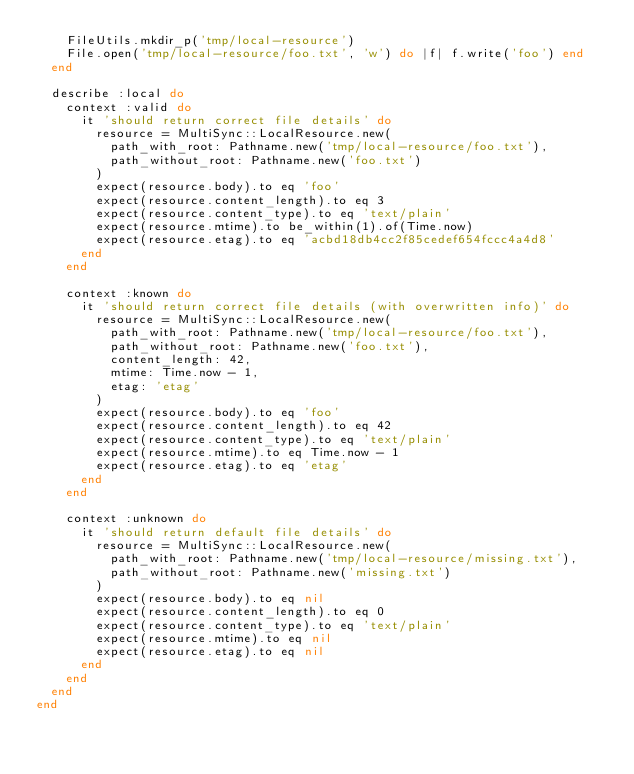<code> <loc_0><loc_0><loc_500><loc_500><_Ruby_>    FileUtils.mkdir_p('tmp/local-resource')
    File.open('tmp/local-resource/foo.txt', 'w') do |f| f.write('foo') end
  end

  describe :local do
    context :valid do
      it 'should return correct file details' do
        resource = MultiSync::LocalResource.new(
          path_with_root: Pathname.new('tmp/local-resource/foo.txt'),
          path_without_root: Pathname.new('foo.txt')
        )
        expect(resource.body).to eq 'foo'
        expect(resource.content_length).to eq 3
        expect(resource.content_type).to eq 'text/plain'
        expect(resource.mtime).to be_within(1).of(Time.now)
        expect(resource.etag).to eq 'acbd18db4cc2f85cedef654fccc4a4d8'
      end
    end

    context :known do
      it 'should return correct file details (with overwritten info)' do
        resource = MultiSync::LocalResource.new(
          path_with_root: Pathname.new('tmp/local-resource/foo.txt'),
          path_without_root: Pathname.new('foo.txt'),
          content_length: 42,
          mtime: Time.now - 1,
          etag: 'etag'
        )
        expect(resource.body).to eq 'foo'
        expect(resource.content_length).to eq 42
        expect(resource.content_type).to eq 'text/plain'
        expect(resource.mtime).to eq Time.now - 1
        expect(resource.etag).to eq 'etag'
      end
    end

    context :unknown do
      it 'should return default file details' do
        resource = MultiSync::LocalResource.new(
          path_with_root: Pathname.new('tmp/local-resource/missing.txt'),
          path_without_root: Pathname.new('missing.txt')
        )
        expect(resource.body).to eq nil
        expect(resource.content_length).to eq 0
        expect(resource.content_type).to eq 'text/plain'
        expect(resource.mtime).to eq nil
        expect(resource.etag).to eq nil
      end
    end
  end
end
</code> 